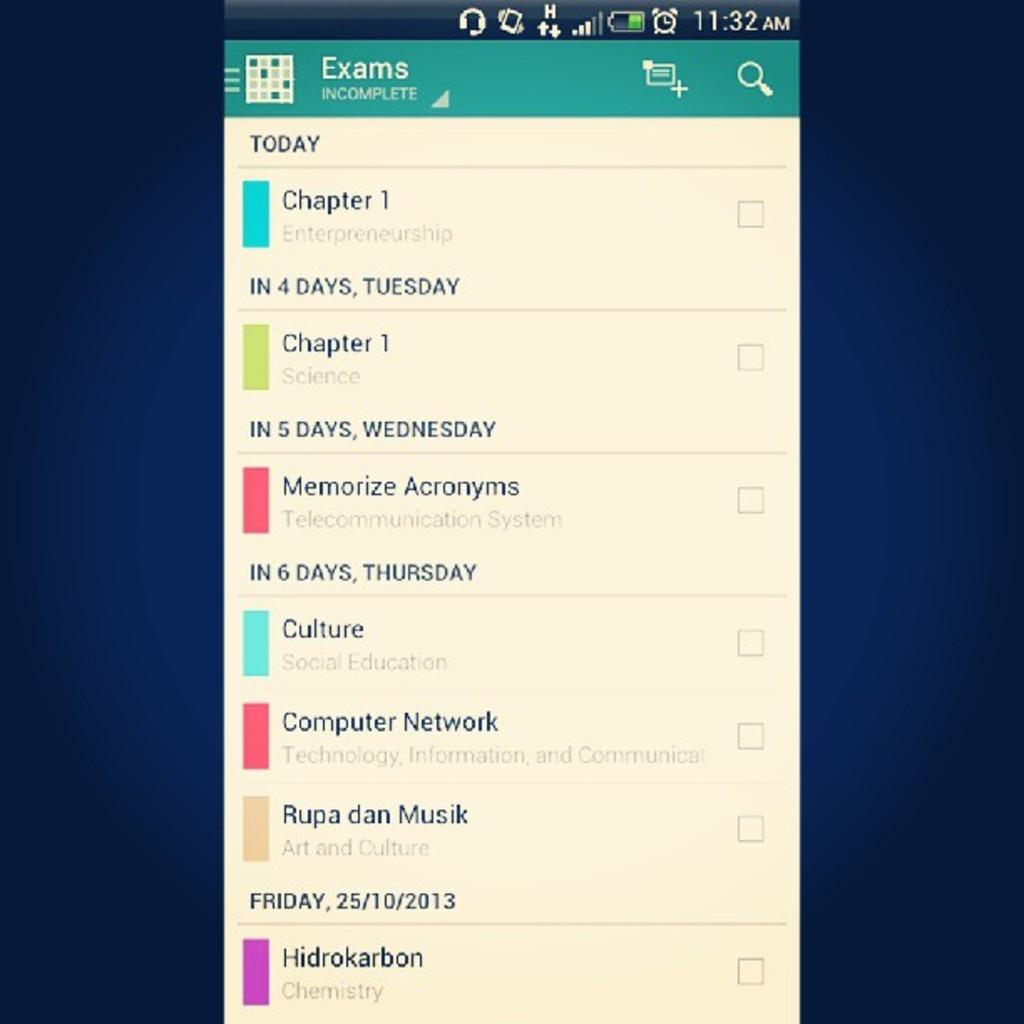<image>
Render a clear and concise summary of the photo. a phone with a screen showing days with exam schedule 